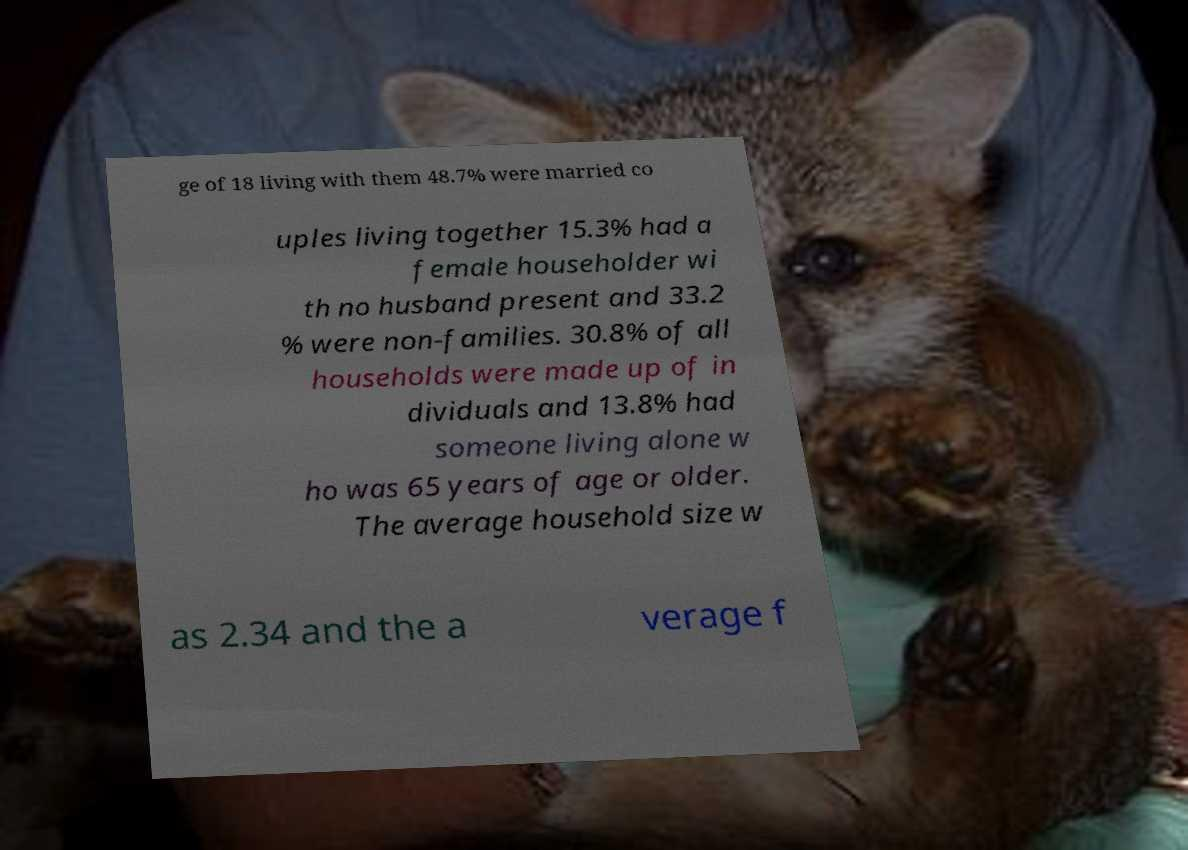Can you accurately transcribe the text from the provided image for me? ge of 18 living with them 48.7% were married co uples living together 15.3% had a female householder wi th no husband present and 33.2 % were non-families. 30.8% of all households were made up of in dividuals and 13.8% had someone living alone w ho was 65 years of age or older. The average household size w as 2.34 and the a verage f 